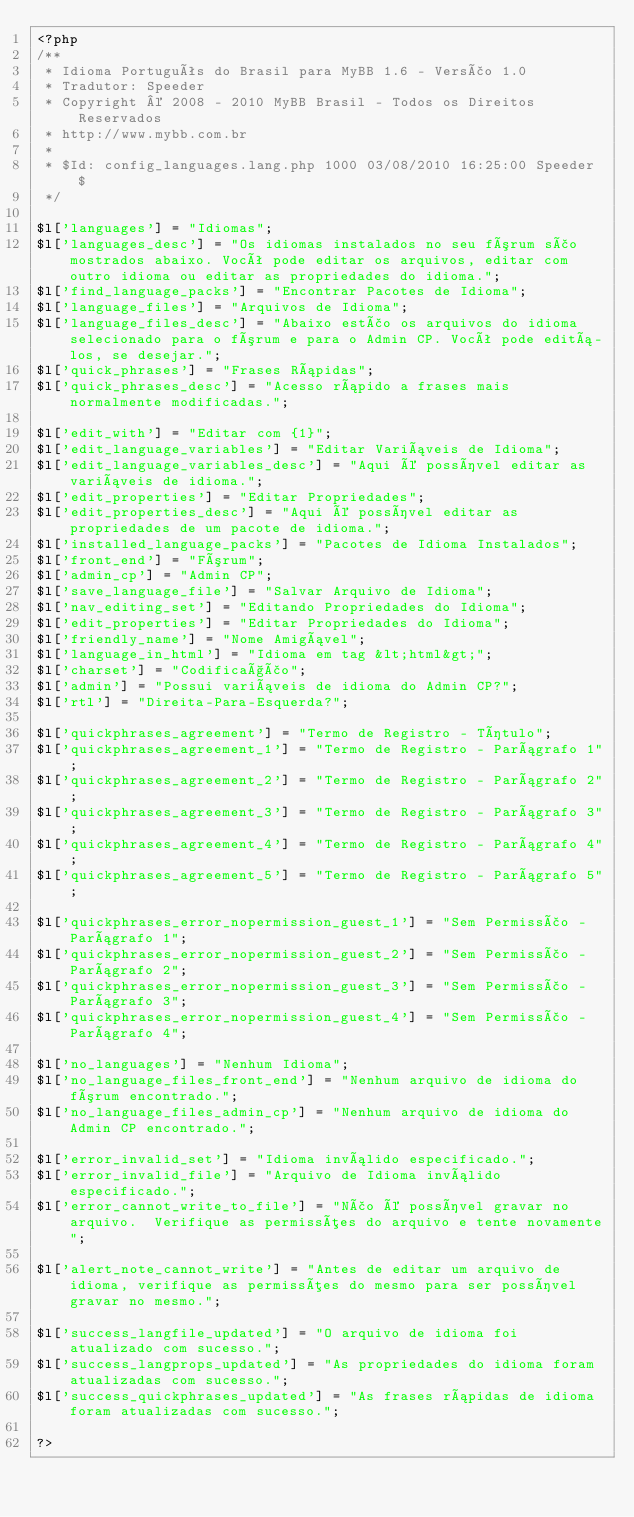Convert code to text. <code><loc_0><loc_0><loc_500><loc_500><_PHP_><?php
/**
 * Idioma Português do Brasil para MyBB 1.6 - Versão 1.0
 * Tradutor: Speeder
 * Copyright © 2008 - 2010 MyBB Brasil - Todos os Direitos Reservados
 * http://www.mybb.com.br
 *
 * $Id: config_languages.lang.php 1000 03/08/2010 16:25:00 Speeder $
 */

$l['languages'] = "Idiomas";
$l['languages_desc'] = "Os idiomas instalados no seu fórum são mostrados abaixo. Você pode editar os arquivos, editar com outro idioma ou editar as propriedades do idioma.";
$l['find_language_packs'] = "Encontrar Pacotes de Idioma";
$l['language_files'] = "Arquivos de Idioma";
$l['language_files_desc'] = "Abaixo estão os arquivos do idioma selecionado para o fórum e para o Admin CP. Você pode editá-los, se desejar.";
$l['quick_phrases'] = "Frases Rápidas";
$l['quick_phrases_desc'] = "Acesso rápido a frases mais normalmente modificadas.";

$l['edit_with'] = "Editar com {1}";
$l['edit_language_variables'] = "Editar Variáveis de Idioma";
$l['edit_language_variables_desc'] = "Aqui é possível editar as variáveis de idioma.";
$l['edit_properties'] = "Editar Propriedades";
$l['edit_properties_desc'] = "Aqui é possível editar as propriedades de um pacote de idioma.";
$l['installed_language_packs'] = "Pacotes de Idioma Instalados";
$l['front_end'] = "Fórum";
$l['admin_cp'] = "Admin CP";
$l['save_language_file'] = "Salvar Arquivo de Idioma";
$l['nav_editing_set'] = "Editando Propriedades do Idioma";
$l['edit_properties'] = "Editar Propriedades do Idioma";
$l['friendly_name'] = "Nome Amigável";
$l['language_in_html'] = "Idioma em tag &lt;html&gt;";
$l['charset'] = "Codificação";
$l['admin'] = "Possui variáveis de idioma do Admin CP?";
$l['rtl'] = "Direita-Para-Esquerda?";

$l['quickphrases_agreement'] = "Termo de Registro - Título";
$l['quickphrases_agreement_1'] = "Termo de Registro - Parágrafo 1";
$l['quickphrases_agreement_2'] = "Termo de Registro - Parágrafo 2";
$l['quickphrases_agreement_3'] = "Termo de Registro - Parágrafo 3";
$l['quickphrases_agreement_4'] = "Termo de Registro - Parágrafo 4";
$l['quickphrases_agreement_5'] = "Termo de Registro - Parágrafo 5";

$l['quickphrases_error_nopermission_guest_1'] = "Sem Permissão - Parágrafo 1";
$l['quickphrases_error_nopermission_guest_2'] = "Sem Permissão - Parágrafo 2";
$l['quickphrases_error_nopermission_guest_3'] = "Sem Permissão - Parágrafo 3";
$l['quickphrases_error_nopermission_guest_4'] = "Sem Permissão - Parágrafo 4";

$l['no_languages'] = "Nenhum Idioma";
$l['no_language_files_front_end'] = "Nenhum arquivo de idioma do fórum encontrado.";
$l['no_language_files_admin_cp'] = "Nenhum arquivo de idioma do Admin CP encontrado.";

$l['error_invalid_set'] = "Idioma inválido especificado.";
$l['error_invalid_file'] = "Arquivo de Idioma inválido especificado.";
$l['error_cannot_write_to_file'] = "Não é possível gravar no arquivo.  Verifique as permissões do arquivo e tente novamente";

$l['alert_note_cannot_write'] = "Antes de editar um arquivo de idioma, verifique as permissões do mesmo para ser possível gravar no mesmo.";

$l['success_langfile_updated'] = "O arquivo de idioma foi atualizado com sucesso.";
$l['success_langprops_updated'] = "As propriedades do idioma foram atualizadas com sucesso.";
$l['success_quickphrases_updated'] = "As frases rápidas de idioma foram atualizadas com sucesso.";

?></code> 